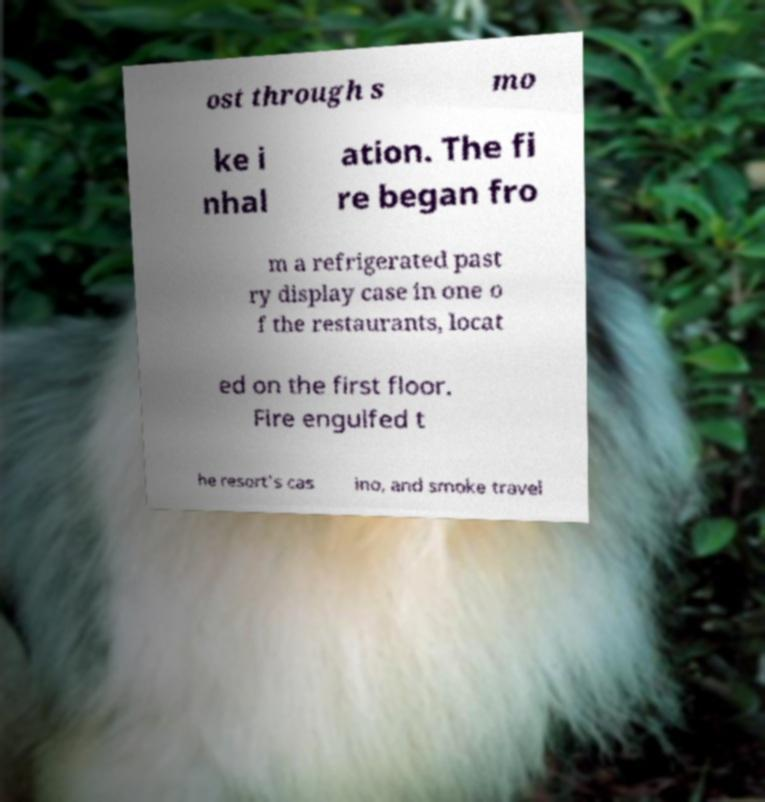I need the written content from this picture converted into text. Can you do that? ost through s mo ke i nhal ation. The fi re began fro m a refrigerated past ry display case in one o f the restaurants, locat ed on the first floor. Fire engulfed t he resort's cas ino, and smoke travel 